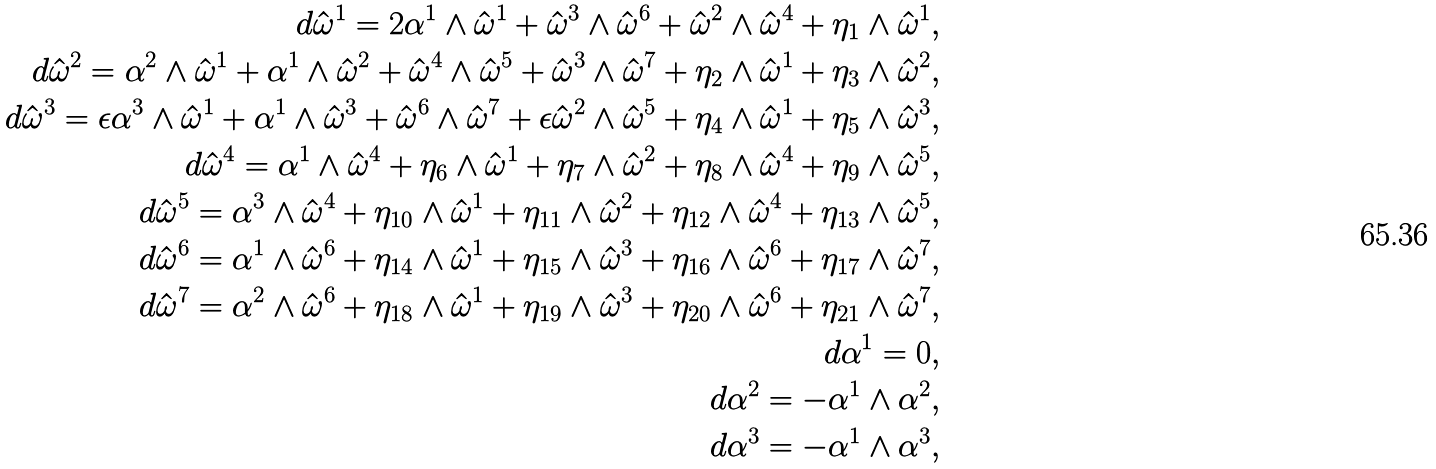Convert formula to latex. <formula><loc_0><loc_0><loc_500><loc_500>d \hat { \omega } ^ { 1 } = 2 \alpha ^ { 1 } \wedge \hat { \omega } ^ { 1 } + \hat { \omega } ^ { 3 } \wedge \hat { \omega } ^ { 6 } + \hat { \omega } ^ { 2 } \wedge \hat { \omega } ^ { 4 } + \eta _ { 1 } \wedge \hat { \omega } ^ { 1 } , \\ d \hat { \omega } ^ { 2 } = \alpha ^ { 2 } \wedge \hat { \omega } ^ { 1 } + \alpha ^ { 1 } \wedge \hat { \omega } ^ { 2 } + \hat { \omega } ^ { 4 } \wedge \hat { \omega } ^ { 5 } + \hat { \omega } ^ { 3 } \wedge \hat { \omega } ^ { 7 } + \eta _ { 2 } \wedge \hat { \omega } ^ { 1 } + \eta _ { 3 } \wedge \hat { \omega } ^ { 2 } , \\ d \hat { \omega } ^ { 3 } = \epsilon \alpha ^ { 3 } \wedge \hat { \omega } ^ { 1 } + \alpha ^ { 1 } \wedge \hat { \omega } ^ { 3 } + \hat { \omega } ^ { 6 } \wedge \hat { \omega } ^ { 7 } + \epsilon \hat { \omega } ^ { 2 } \wedge \hat { \omega } ^ { 5 } + \eta _ { 4 } \wedge \hat { \omega } ^ { 1 } + \eta _ { 5 } \wedge \hat { \omega } ^ { 3 } , \\ d \hat { \omega } ^ { 4 } = \alpha ^ { 1 } \wedge \hat { \omega } ^ { 4 } + \eta _ { 6 } \wedge \hat { \omega } ^ { 1 } + \eta _ { 7 } \wedge \hat { \omega } ^ { 2 } + \eta _ { 8 } \wedge \hat { \omega } ^ { 4 } + \eta _ { 9 } \wedge \hat { \omega } ^ { 5 } , \\ d \hat { \omega } ^ { 5 } = \alpha ^ { 3 } \wedge \hat { \omega } ^ { 4 } + \eta _ { 1 0 } \wedge \hat { \omega } ^ { 1 } + \eta _ { 1 1 } \wedge \hat { \omega } ^ { 2 } + \eta _ { 1 2 } \wedge \hat { \omega } ^ { 4 } + \eta _ { 1 3 } \wedge \hat { \omega } ^ { 5 } , \\ d \hat { \omega } ^ { 6 } = \alpha ^ { 1 } \wedge \hat { \omega } ^ { 6 } + \eta _ { 1 4 } \wedge \hat { \omega } ^ { 1 } + \eta _ { 1 5 } \wedge \hat { \omega } ^ { 3 } + \eta _ { 1 6 } \wedge \hat { \omega } ^ { 6 } + \eta _ { 1 7 } \wedge \hat { \omega } ^ { 7 } , \\ d \hat { \omega } ^ { 7 } = \alpha ^ { 2 } \wedge \hat { \omega } ^ { 6 } + \eta _ { 1 8 } \wedge \hat { \omega } ^ { 1 } + \eta _ { 1 9 } \wedge \hat { \omega } ^ { 3 } + \eta _ { 2 0 } \wedge \hat { \omega } ^ { 6 } + \eta _ { 2 1 } \wedge \hat { \omega } ^ { 7 } , \\ d \alpha ^ { 1 } = 0 , \\ d \alpha ^ { 2 } = - \alpha ^ { 1 } \wedge \alpha ^ { 2 } , \\ d \alpha ^ { 3 } = - \alpha ^ { 1 } \wedge \alpha ^ { 3 } ,</formula> 